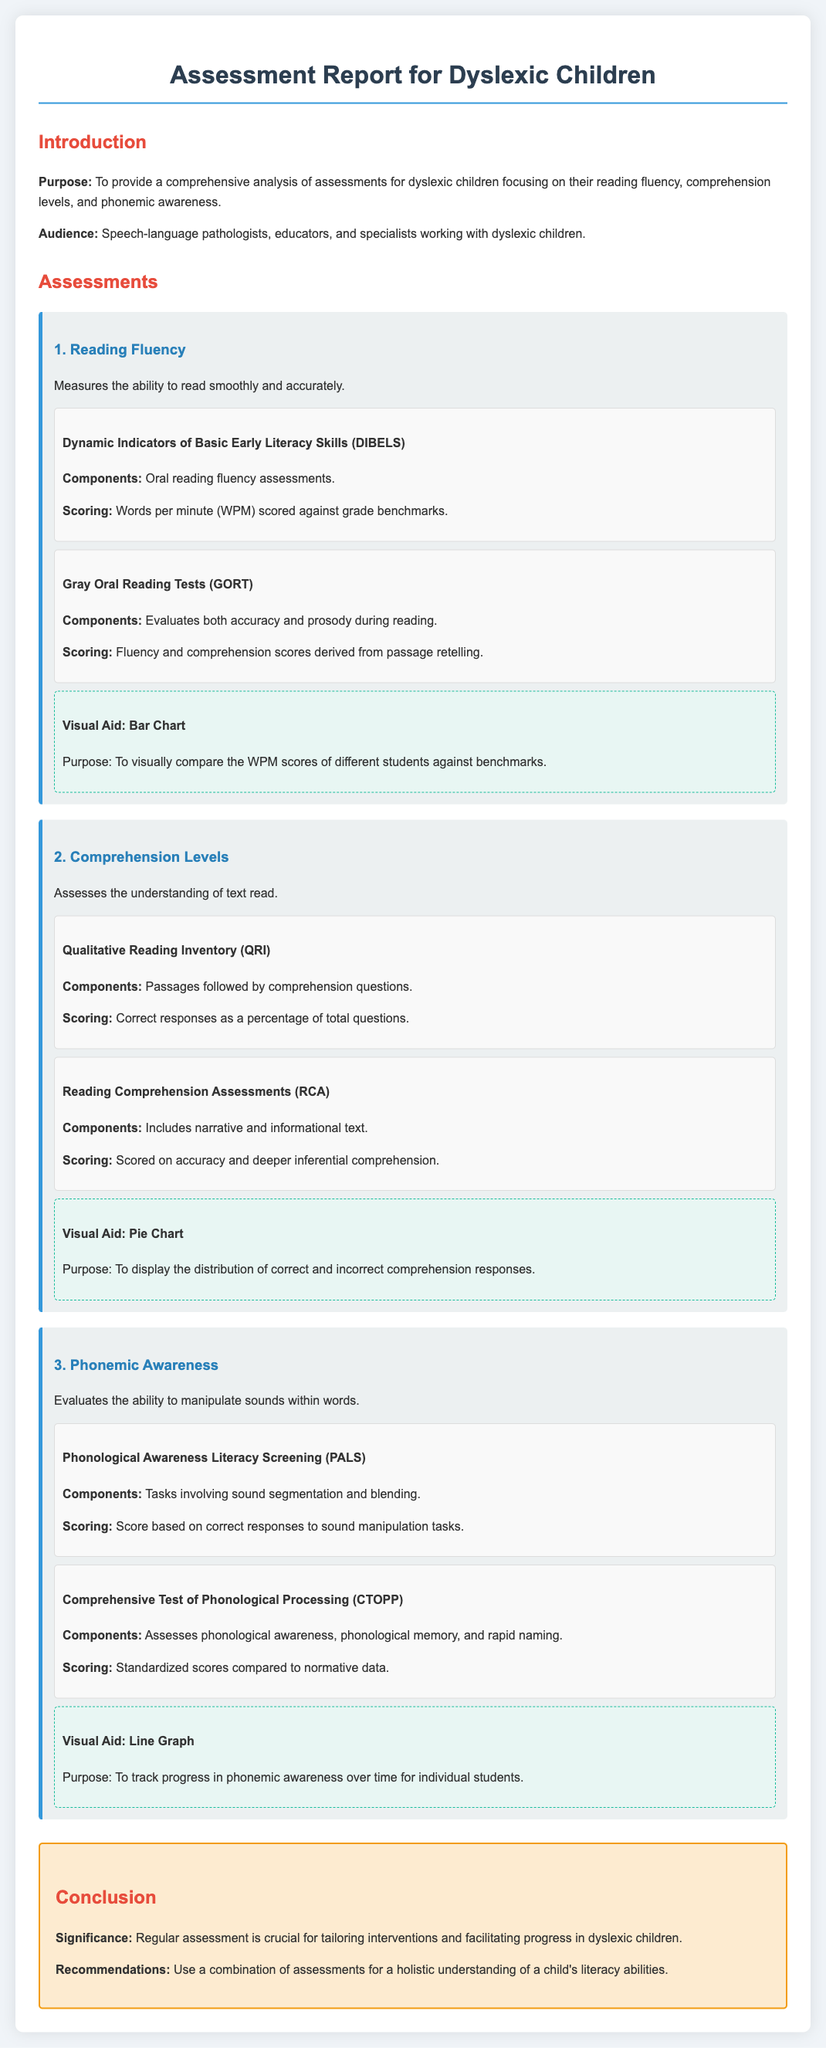what is the purpose of the assessment report? The purpose is to provide a comprehensive analysis of assessments for dyslexic children focusing on their reading fluency, comprehension levels, and phonemic awareness.
Answer: comprehensive analysis of assessments for dyslexic children who is the intended audience for the report? The intended audience includes speech-language pathologists, educators, and specialists working with dyslexic children.
Answer: speech-language pathologists, educators, and specialists what assessment measures reading fluency? The Dynamic Indicators of Basic Early Literacy Skills (DIBELS) measures reading fluency.
Answer: Dynamic Indicators of Basic Early Literacy Skills (DIBELS) what scoring method is used in the Gray Oral Reading Tests? The scoring method includes fluency and comprehension scores derived from passage retelling.
Answer: fluency and comprehension scores which visual aid is used to compare WPM scores? The visual aid is a bar chart designed to compare the WPM scores of different students against benchmarks.
Answer: bar chart how is phonemic awareness assessed? Phonemic awareness is assessed through tasks involving sound segmentation and blending in the Phonological Awareness Literacy Screening (PALS).
Answer: tasks involving sound segmentation and blending what percentage measures comprehension responses in the Qualitative Reading Inventory? The scoring measures correct responses as a percentage of total questions.
Answer: percentage of total questions what does the conclusion stress as crucial for dyslexic children? The conclusion stresses that regular assessment is crucial for tailoring interventions and facilitating progress in dyslexic children.
Answer: regular assessment 